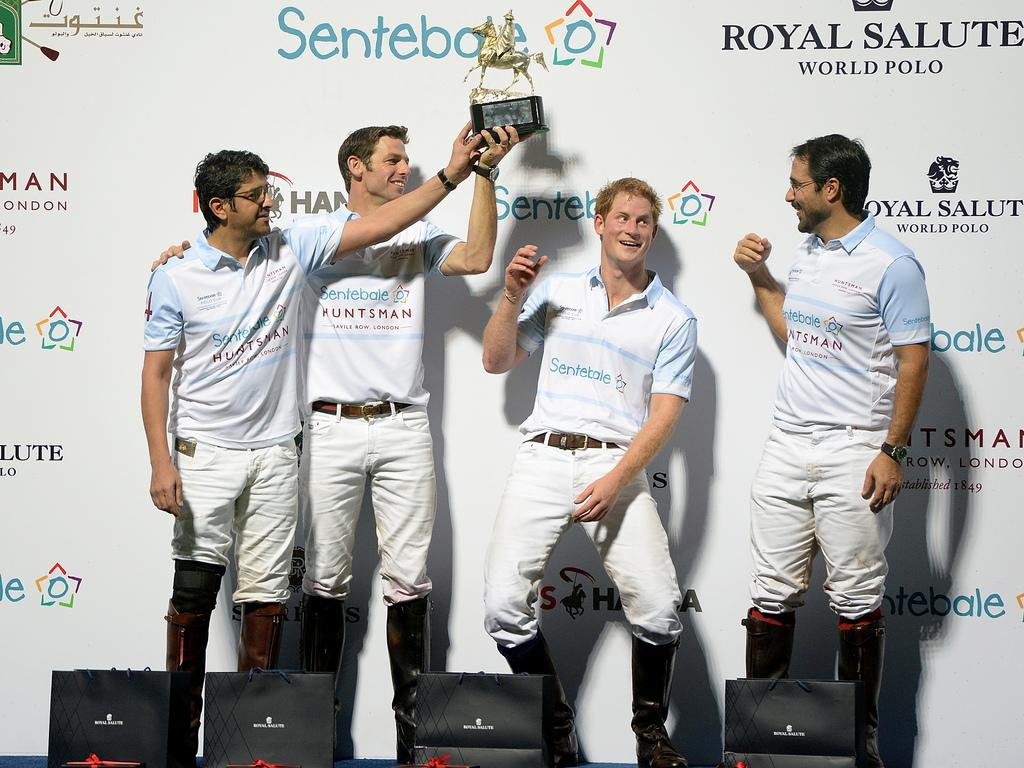<image>
Give a short and clear explanation of the subsequent image. Four men stand in front of a wall that says Royal Salute on it. 